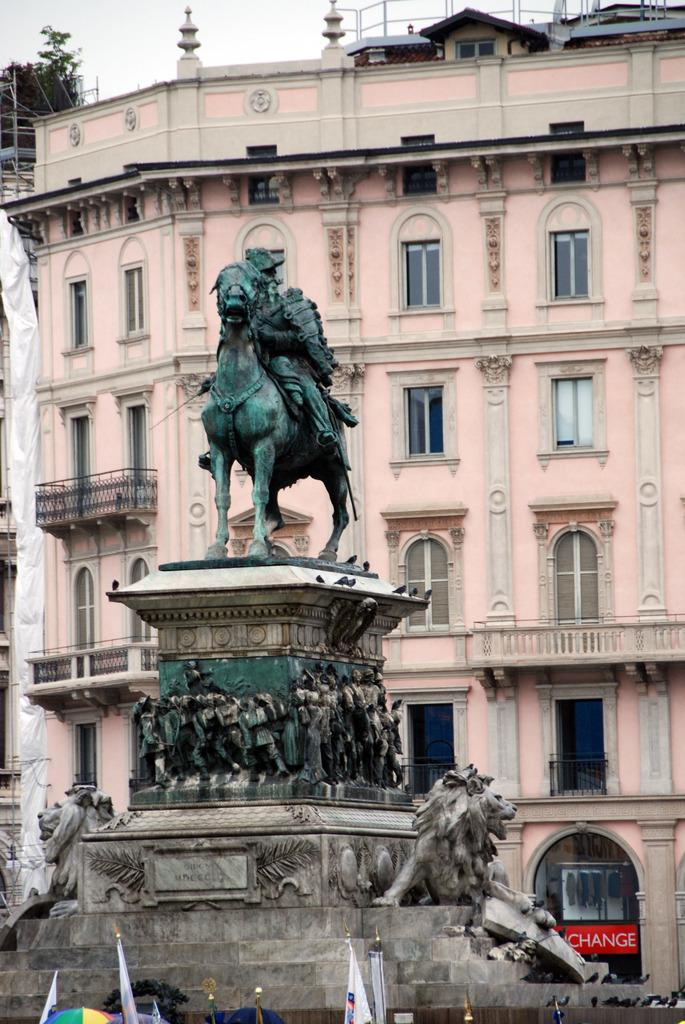Provide a one-sentence caption for the provided image. A statue of a man on a horse sits atop a pedestal in front of a machine that says Change in the background. 